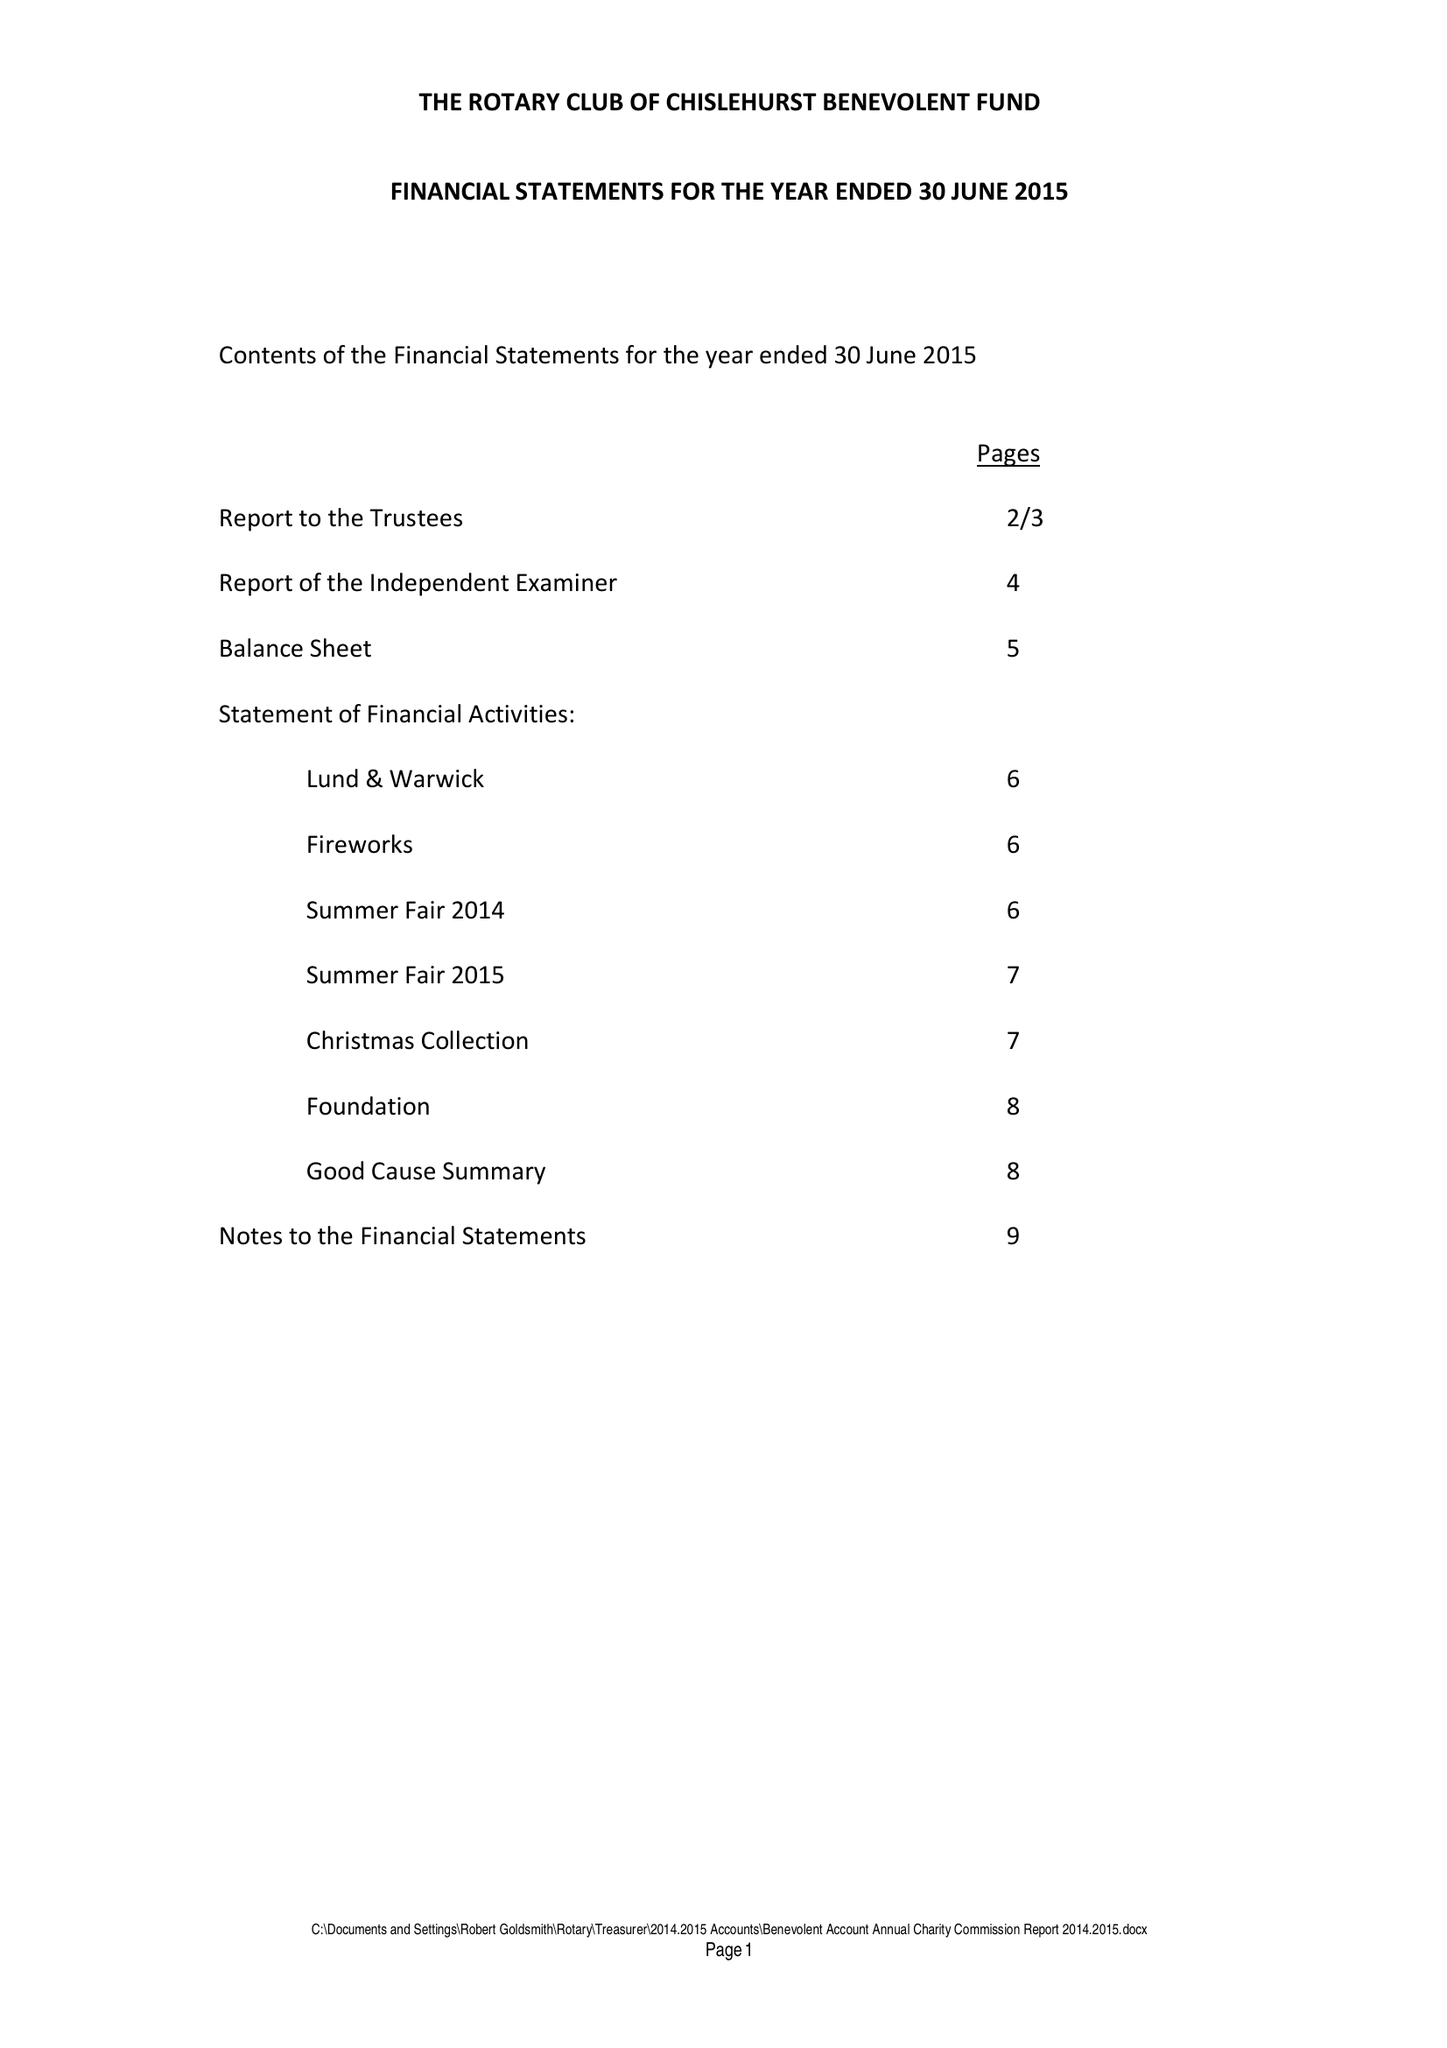What is the value for the address__street_line?
Answer the question using a single word or phrase. CHELSFIELD LANE 